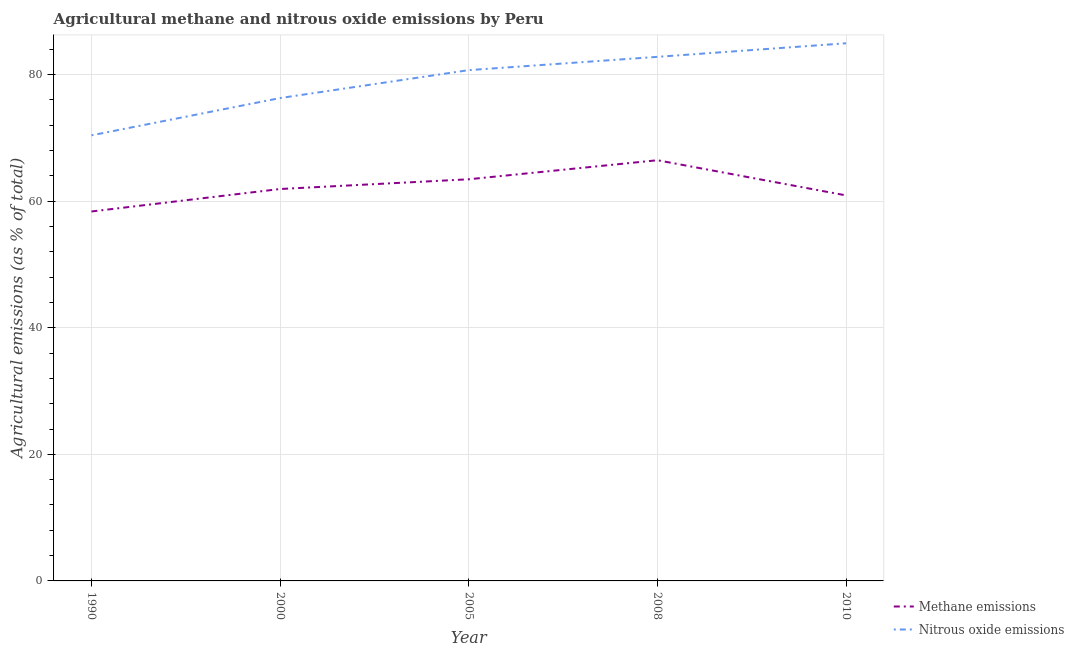Does the line corresponding to amount of nitrous oxide emissions intersect with the line corresponding to amount of methane emissions?
Provide a succinct answer. No. Is the number of lines equal to the number of legend labels?
Give a very brief answer. Yes. What is the amount of methane emissions in 1990?
Ensure brevity in your answer.  58.38. Across all years, what is the maximum amount of nitrous oxide emissions?
Provide a succinct answer. 84.95. Across all years, what is the minimum amount of nitrous oxide emissions?
Give a very brief answer. 70.41. In which year was the amount of methane emissions maximum?
Offer a very short reply. 2008. What is the total amount of nitrous oxide emissions in the graph?
Provide a succinct answer. 395.17. What is the difference between the amount of nitrous oxide emissions in 1990 and that in 2008?
Provide a succinct answer. -12.4. What is the difference between the amount of nitrous oxide emissions in 2008 and the amount of methane emissions in 2000?
Your answer should be very brief. 20.88. What is the average amount of nitrous oxide emissions per year?
Provide a succinct answer. 79.03. In the year 2010, what is the difference between the amount of methane emissions and amount of nitrous oxide emissions?
Ensure brevity in your answer.  -24.03. What is the ratio of the amount of nitrous oxide emissions in 2005 to that in 2010?
Your answer should be very brief. 0.95. Is the amount of methane emissions in 1990 less than that in 2008?
Provide a short and direct response. Yes. Is the difference between the amount of nitrous oxide emissions in 1990 and 2005 greater than the difference between the amount of methane emissions in 1990 and 2005?
Provide a succinct answer. No. What is the difference between the highest and the second highest amount of nitrous oxide emissions?
Your response must be concise. 2.14. What is the difference between the highest and the lowest amount of methane emissions?
Provide a succinct answer. 8.1. Is the sum of the amount of methane emissions in 1990 and 2008 greater than the maximum amount of nitrous oxide emissions across all years?
Provide a succinct answer. Yes. Is the amount of nitrous oxide emissions strictly greater than the amount of methane emissions over the years?
Make the answer very short. Yes. Is the amount of nitrous oxide emissions strictly less than the amount of methane emissions over the years?
Keep it short and to the point. No. How many lines are there?
Ensure brevity in your answer.  2. How many years are there in the graph?
Offer a terse response. 5. Does the graph contain grids?
Provide a short and direct response. Yes. Where does the legend appear in the graph?
Your answer should be compact. Bottom right. What is the title of the graph?
Make the answer very short. Agricultural methane and nitrous oxide emissions by Peru. Does "Underweight" appear as one of the legend labels in the graph?
Ensure brevity in your answer.  No. What is the label or title of the Y-axis?
Provide a short and direct response. Agricultural emissions (as % of total). What is the Agricultural emissions (as % of total) in Methane emissions in 1990?
Give a very brief answer. 58.38. What is the Agricultural emissions (as % of total) of Nitrous oxide emissions in 1990?
Provide a short and direct response. 70.41. What is the Agricultural emissions (as % of total) of Methane emissions in 2000?
Provide a succinct answer. 61.93. What is the Agricultural emissions (as % of total) in Nitrous oxide emissions in 2000?
Your answer should be compact. 76.3. What is the Agricultural emissions (as % of total) in Methane emissions in 2005?
Keep it short and to the point. 63.46. What is the Agricultural emissions (as % of total) of Nitrous oxide emissions in 2005?
Provide a short and direct response. 80.71. What is the Agricultural emissions (as % of total) of Methane emissions in 2008?
Keep it short and to the point. 66.47. What is the Agricultural emissions (as % of total) of Nitrous oxide emissions in 2008?
Keep it short and to the point. 82.81. What is the Agricultural emissions (as % of total) in Methane emissions in 2010?
Offer a terse response. 60.92. What is the Agricultural emissions (as % of total) in Nitrous oxide emissions in 2010?
Keep it short and to the point. 84.95. Across all years, what is the maximum Agricultural emissions (as % of total) in Methane emissions?
Provide a succinct answer. 66.47. Across all years, what is the maximum Agricultural emissions (as % of total) in Nitrous oxide emissions?
Your response must be concise. 84.95. Across all years, what is the minimum Agricultural emissions (as % of total) in Methane emissions?
Provide a short and direct response. 58.38. Across all years, what is the minimum Agricultural emissions (as % of total) of Nitrous oxide emissions?
Your response must be concise. 70.41. What is the total Agricultural emissions (as % of total) of Methane emissions in the graph?
Offer a very short reply. 311.15. What is the total Agricultural emissions (as % of total) of Nitrous oxide emissions in the graph?
Keep it short and to the point. 395.17. What is the difference between the Agricultural emissions (as % of total) in Methane emissions in 1990 and that in 2000?
Your response must be concise. -3.55. What is the difference between the Agricultural emissions (as % of total) in Nitrous oxide emissions in 1990 and that in 2000?
Offer a terse response. -5.89. What is the difference between the Agricultural emissions (as % of total) of Methane emissions in 1990 and that in 2005?
Your response must be concise. -5.09. What is the difference between the Agricultural emissions (as % of total) in Nitrous oxide emissions in 1990 and that in 2005?
Ensure brevity in your answer.  -10.3. What is the difference between the Agricultural emissions (as % of total) of Methane emissions in 1990 and that in 2008?
Your answer should be compact. -8.1. What is the difference between the Agricultural emissions (as % of total) of Nitrous oxide emissions in 1990 and that in 2008?
Offer a very short reply. -12.4. What is the difference between the Agricultural emissions (as % of total) of Methane emissions in 1990 and that in 2010?
Provide a succinct answer. -2.54. What is the difference between the Agricultural emissions (as % of total) in Nitrous oxide emissions in 1990 and that in 2010?
Give a very brief answer. -14.54. What is the difference between the Agricultural emissions (as % of total) in Methane emissions in 2000 and that in 2005?
Provide a succinct answer. -1.54. What is the difference between the Agricultural emissions (as % of total) in Nitrous oxide emissions in 2000 and that in 2005?
Give a very brief answer. -4.41. What is the difference between the Agricultural emissions (as % of total) in Methane emissions in 2000 and that in 2008?
Your answer should be compact. -4.55. What is the difference between the Agricultural emissions (as % of total) of Nitrous oxide emissions in 2000 and that in 2008?
Offer a terse response. -6.51. What is the difference between the Agricultural emissions (as % of total) in Methane emissions in 2000 and that in 2010?
Offer a terse response. 1.01. What is the difference between the Agricultural emissions (as % of total) of Nitrous oxide emissions in 2000 and that in 2010?
Your response must be concise. -8.65. What is the difference between the Agricultural emissions (as % of total) in Methane emissions in 2005 and that in 2008?
Offer a terse response. -3.01. What is the difference between the Agricultural emissions (as % of total) of Nitrous oxide emissions in 2005 and that in 2008?
Provide a succinct answer. -2.1. What is the difference between the Agricultural emissions (as % of total) in Methane emissions in 2005 and that in 2010?
Your response must be concise. 2.55. What is the difference between the Agricultural emissions (as % of total) in Nitrous oxide emissions in 2005 and that in 2010?
Your answer should be compact. -4.24. What is the difference between the Agricultural emissions (as % of total) in Methane emissions in 2008 and that in 2010?
Your answer should be compact. 5.56. What is the difference between the Agricultural emissions (as % of total) of Nitrous oxide emissions in 2008 and that in 2010?
Your response must be concise. -2.14. What is the difference between the Agricultural emissions (as % of total) of Methane emissions in 1990 and the Agricultural emissions (as % of total) of Nitrous oxide emissions in 2000?
Provide a succinct answer. -17.92. What is the difference between the Agricultural emissions (as % of total) in Methane emissions in 1990 and the Agricultural emissions (as % of total) in Nitrous oxide emissions in 2005?
Your answer should be very brief. -22.33. What is the difference between the Agricultural emissions (as % of total) of Methane emissions in 1990 and the Agricultural emissions (as % of total) of Nitrous oxide emissions in 2008?
Provide a succinct answer. -24.43. What is the difference between the Agricultural emissions (as % of total) of Methane emissions in 1990 and the Agricultural emissions (as % of total) of Nitrous oxide emissions in 2010?
Keep it short and to the point. -26.58. What is the difference between the Agricultural emissions (as % of total) in Methane emissions in 2000 and the Agricultural emissions (as % of total) in Nitrous oxide emissions in 2005?
Your answer should be very brief. -18.78. What is the difference between the Agricultural emissions (as % of total) in Methane emissions in 2000 and the Agricultural emissions (as % of total) in Nitrous oxide emissions in 2008?
Your response must be concise. -20.88. What is the difference between the Agricultural emissions (as % of total) in Methane emissions in 2000 and the Agricultural emissions (as % of total) in Nitrous oxide emissions in 2010?
Make the answer very short. -23.03. What is the difference between the Agricultural emissions (as % of total) in Methane emissions in 2005 and the Agricultural emissions (as % of total) in Nitrous oxide emissions in 2008?
Ensure brevity in your answer.  -19.34. What is the difference between the Agricultural emissions (as % of total) in Methane emissions in 2005 and the Agricultural emissions (as % of total) in Nitrous oxide emissions in 2010?
Ensure brevity in your answer.  -21.49. What is the difference between the Agricultural emissions (as % of total) in Methane emissions in 2008 and the Agricultural emissions (as % of total) in Nitrous oxide emissions in 2010?
Your answer should be compact. -18.48. What is the average Agricultural emissions (as % of total) in Methane emissions per year?
Provide a short and direct response. 62.23. What is the average Agricultural emissions (as % of total) of Nitrous oxide emissions per year?
Make the answer very short. 79.03. In the year 1990, what is the difference between the Agricultural emissions (as % of total) of Methane emissions and Agricultural emissions (as % of total) of Nitrous oxide emissions?
Offer a very short reply. -12.03. In the year 2000, what is the difference between the Agricultural emissions (as % of total) of Methane emissions and Agricultural emissions (as % of total) of Nitrous oxide emissions?
Keep it short and to the point. -14.37. In the year 2005, what is the difference between the Agricultural emissions (as % of total) of Methane emissions and Agricultural emissions (as % of total) of Nitrous oxide emissions?
Make the answer very short. -17.25. In the year 2008, what is the difference between the Agricultural emissions (as % of total) of Methane emissions and Agricultural emissions (as % of total) of Nitrous oxide emissions?
Keep it short and to the point. -16.34. In the year 2010, what is the difference between the Agricultural emissions (as % of total) in Methane emissions and Agricultural emissions (as % of total) in Nitrous oxide emissions?
Your answer should be very brief. -24.03. What is the ratio of the Agricultural emissions (as % of total) in Methane emissions in 1990 to that in 2000?
Your response must be concise. 0.94. What is the ratio of the Agricultural emissions (as % of total) of Nitrous oxide emissions in 1990 to that in 2000?
Offer a terse response. 0.92. What is the ratio of the Agricultural emissions (as % of total) in Methane emissions in 1990 to that in 2005?
Offer a very short reply. 0.92. What is the ratio of the Agricultural emissions (as % of total) of Nitrous oxide emissions in 1990 to that in 2005?
Ensure brevity in your answer.  0.87. What is the ratio of the Agricultural emissions (as % of total) in Methane emissions in 1990 to that in 2008?
Offer a terse response. 0.88. What is the ratio of the Agricultural emissions (as % of total) of Nitrous oxide emissions in 1990 to that in 2008?
Your response must be concise. 0.85. What is the ratio of the Agricultural emissions (as % of total) of Methane emissions in 1990 to that in 2010?
Your answer should be very brief. 0.96. What is the ratio of the Agricultural emissions (as % of total) of Nitrous oxide emissions in 1990 to that in 2010?
Your answer should be compact. 0.83. What is the ratio of the Agricultural emissions (as % of total) of Methane emissions in 2000 to that in 2005?
Offer a terse response. 0.98. What is the ratio of the Agricultural emissions (as % of total) in Nitrous oxide emissions in 2000 to that in 2005?
Provide a succinct answer. 0.95. What is the ratio of the Agricultural emissions (as % of total) in Methane emissions in 2000 to that in 2008?
Ensure brevity in your answer.  0.93. What is the ratio of the Agricultural emissions (as % of total) of Nitrous oxide emissions in 2000 to that in 2008?
Offer a terse response. 0.92. What is the ratio of the Agricultural emissions (as % of total) of Methane emissions in 2000 to that in 2010?
Your answer should be compact. 1.02. What is the ratio of the Agricultural emissions (as % of total) of Nitrous oxide emissions in 2000 to that in 2010?
Give a very brief answer. 0.9. What is the ratio of the Agricultural emissions (as % of total) of Methane emissions in 2005 to that in 2008?
Provide a succinct answer. 0.95. What is the ratio of the Agricultural emissions (as % of total) in Nitrous oxide emissions in 2005 to that in 2008?
Provide a short and direct response. 0.97. What is the ratio of the Agricultural emissions (as % of total) of Methane emissions in 2005 to that in 2010?
Offer a terse response. 1.04. What is the ratio of the Agricultural emissions (as % of total) in Nitrous oxide emissions in 2005 to that in 2010?
Ensure brevity in your answer.  0.95. What is the ratio of the Agricultural emissions (as % of total) of Methane emissions in 2008 to that in 2010?
Provide a short and direct response. 1.09. What is the ratio of the Agricultural emissions (as % of total) of Nitrous oxide emissions in 2008 to that in 2010?
Offer a terse response. 0.97. What is the difference between the highest and the second highest Agricultural emissions (as % of total) in Methane emissions?
Offer a terse response. 3.01. What is the difference between the highest and the second highest Agricultural emissions (as % of total) in Nitrous oxide emissions?
Your response must be concise. 2.14. What is the difference between the highest and the lowest Agricultural emissions (as % of total) in Methane emissions?
Keep it short and to the point. 8.1. What is the difference between the highest and the lowest Agricultural emissions (as % of total) in Nitrous oxide emissions?
Make the answer very short. 14.54. 